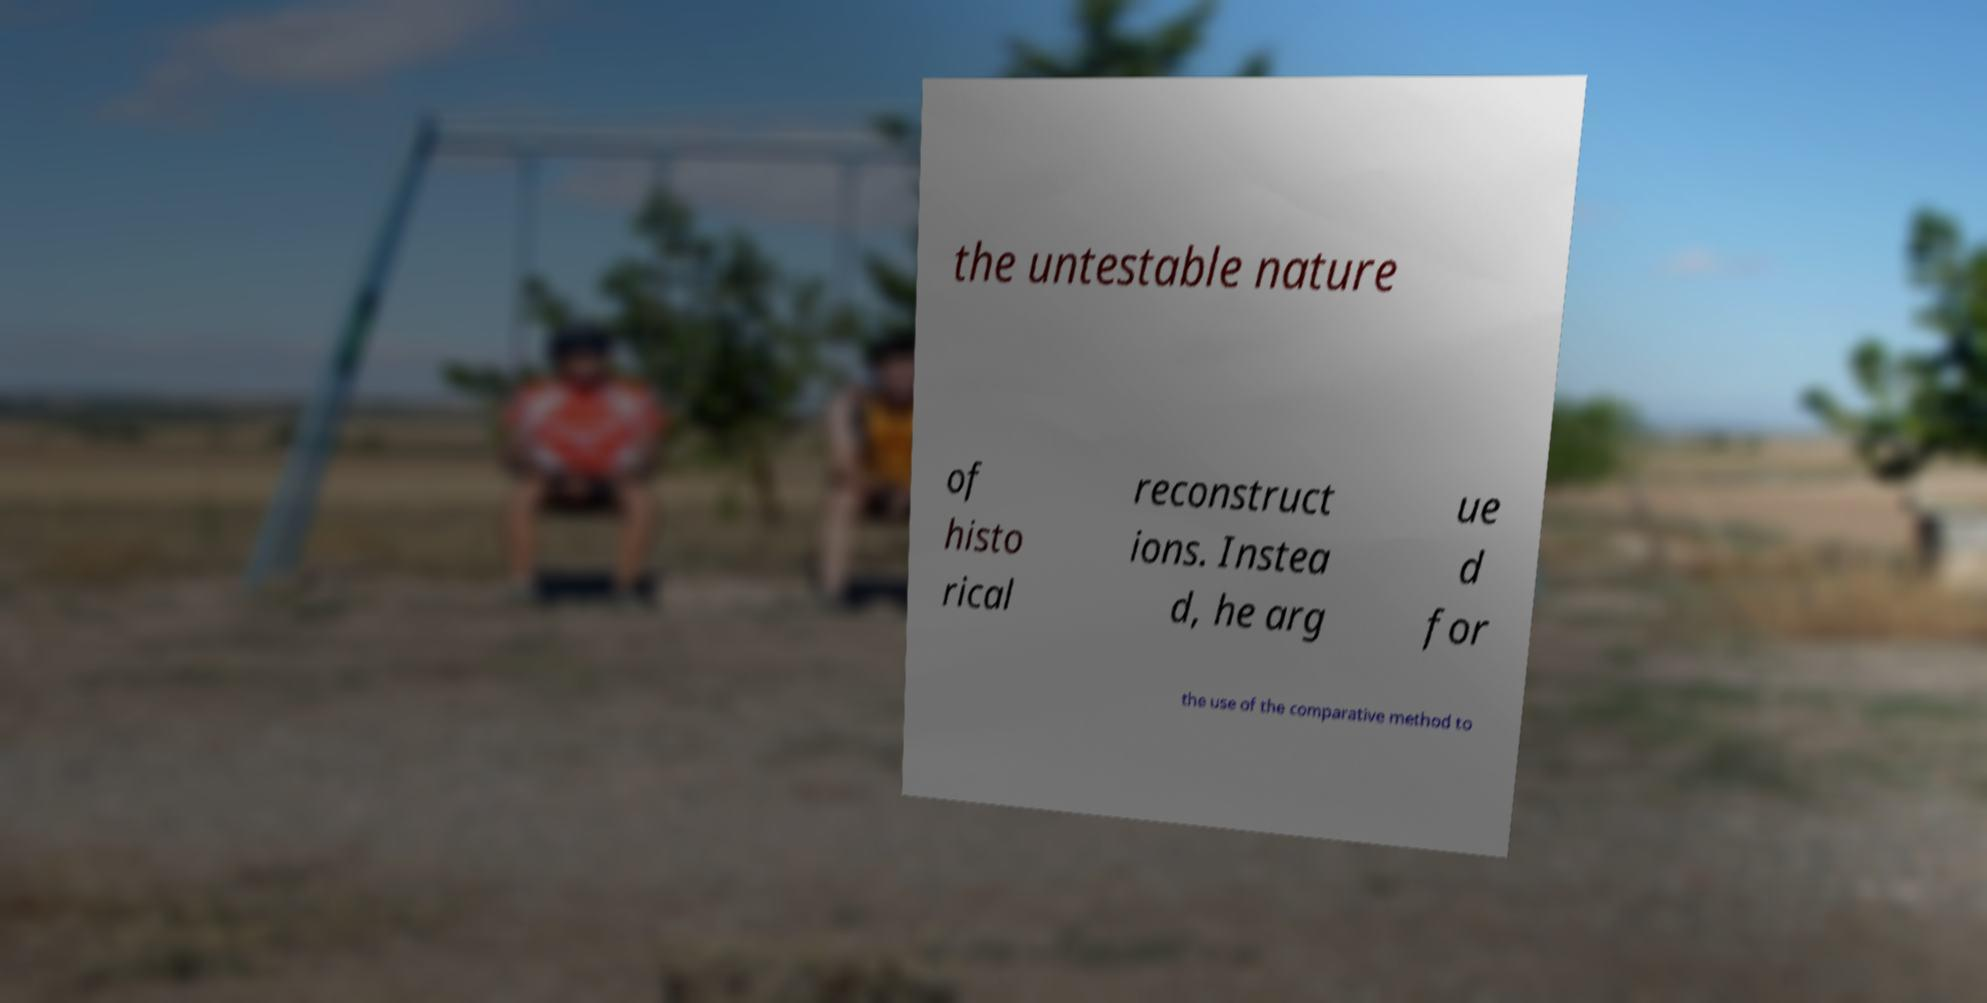Could you assist in decoding the text presented in this image and type it out clearly? the untestable nature of histo rical reconstruct ions. Instea d, he arg ue d for the use of the comparative method to 